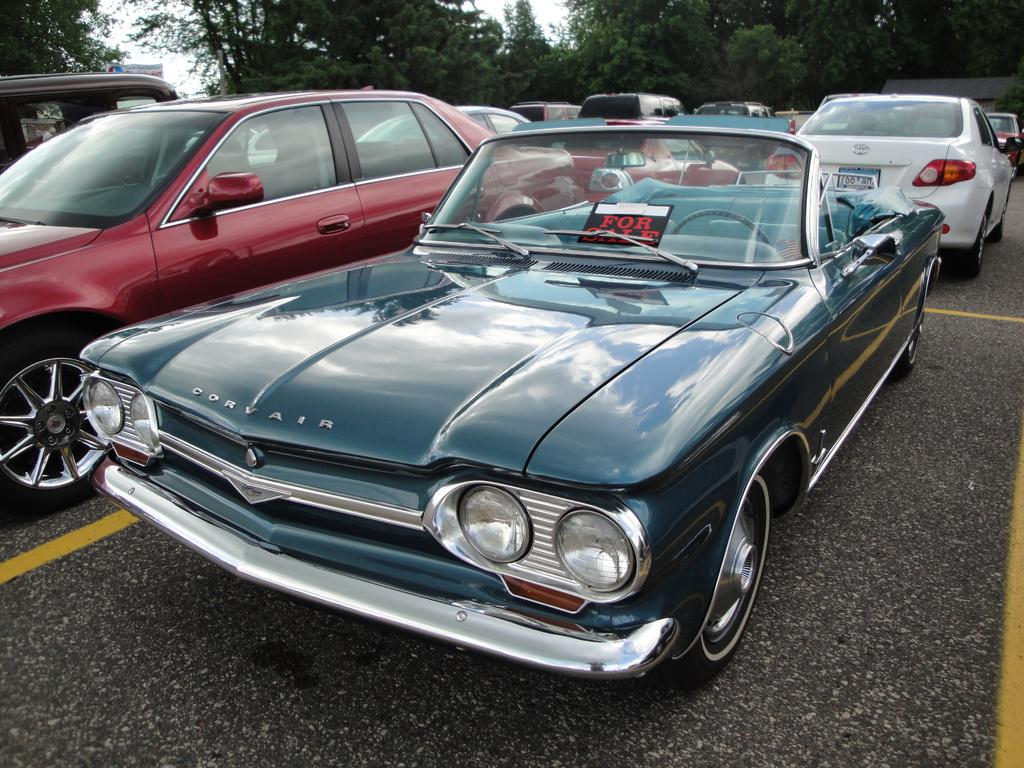What type of vehicles can be seen on the road in the image? There are cars on the road in the image. What is visible at the top of the image? The sky is visible at the top of the image. What type of natural vegetation is present in the image? Trees are present in the image. Can you hear the sound of dinosaurs roaring in the image? There are no dinosaurs present in the image, so it is not possible to hear any roaring sounds from them. 